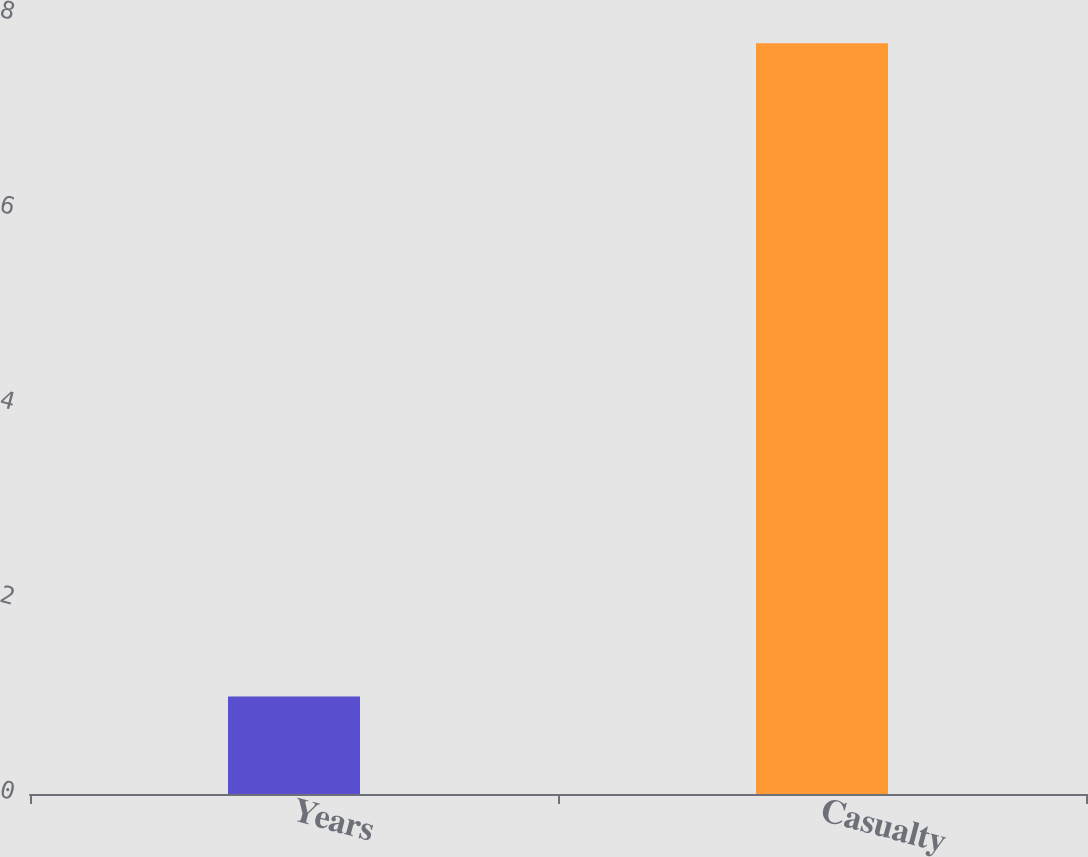<chart> <loc_0><loc_0><loc_500><loc_500><bar_chart><fcel>Years<fcel>Casualty<nl><fcel>1<fcel>7.7<nl></chart> 